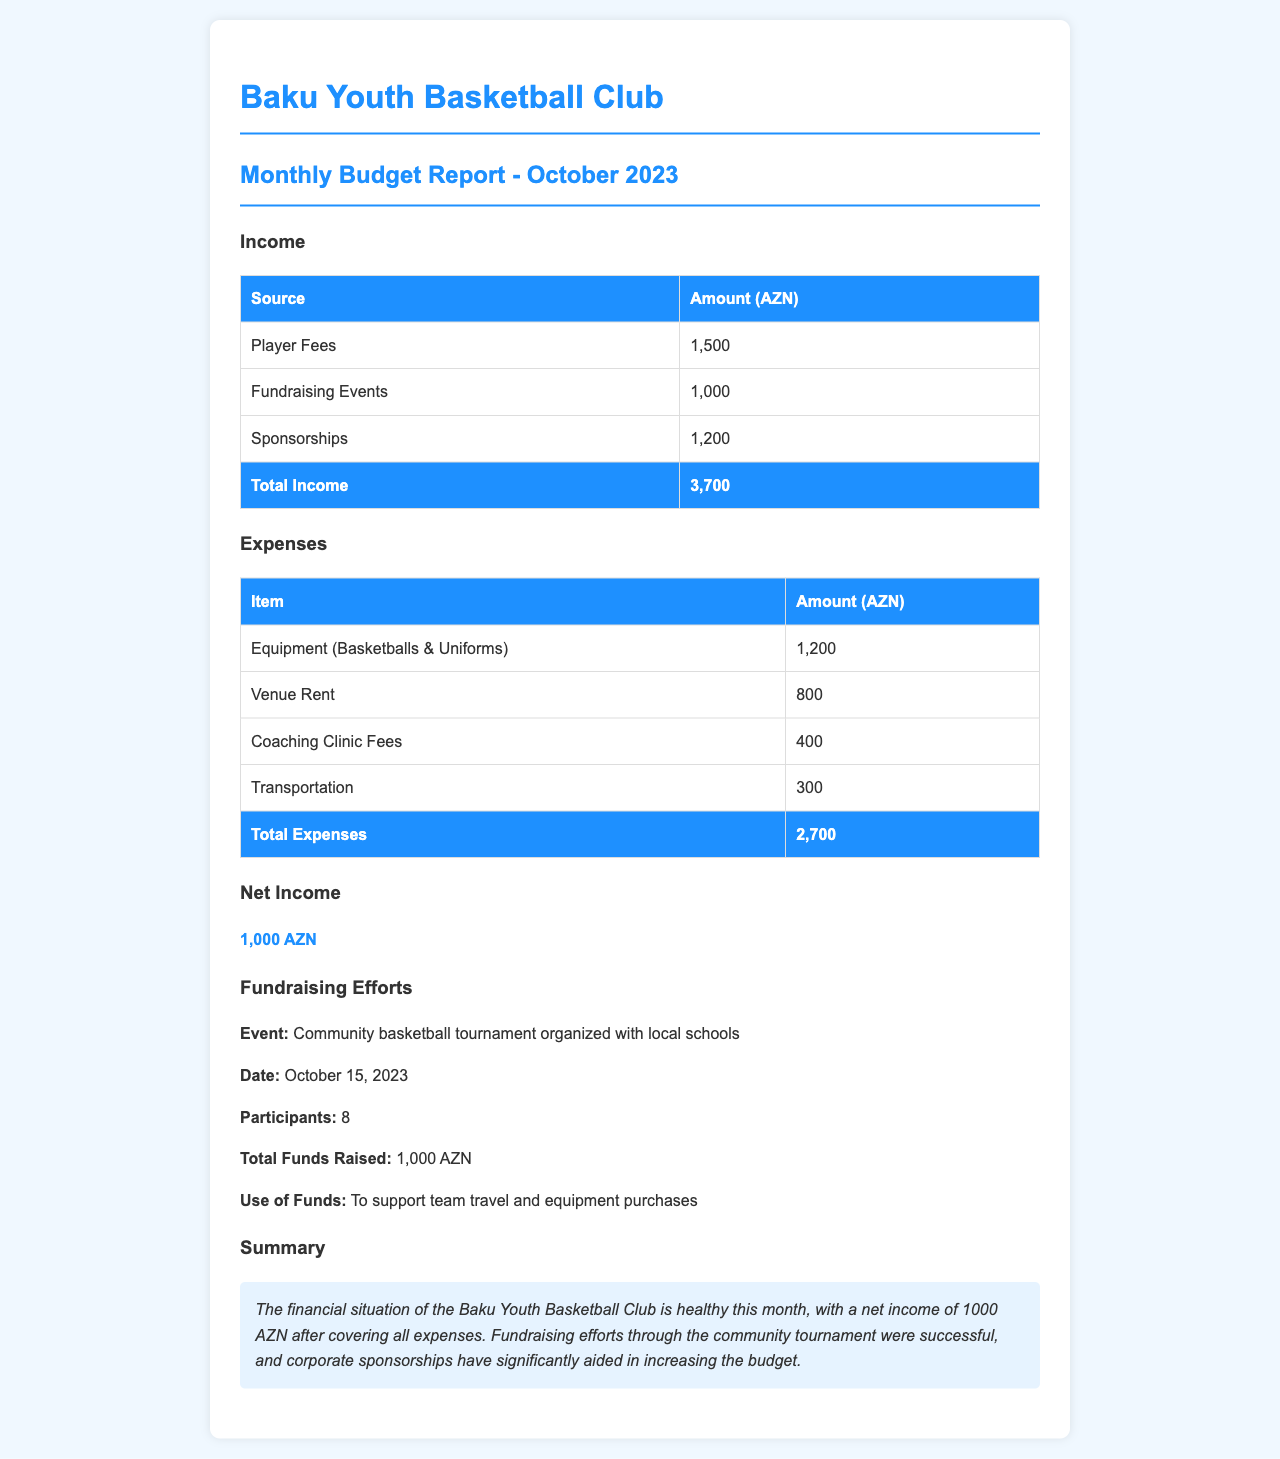What is the total income? The total income is the sum of all income sources listed in the document: 1,500 + 1,000 + 1,200.
Answer: 3,700 AZN What is the total expenses? The total expenses are calculated by adding all expenses listed in the document: 1,200 + 800 + 400 + 300.
Answer: 2,700 AZN What is the net income? The net income is derived from total income minus total expenses: 3,700 - 2,700.
Answer: 1,000 AZN What was the total funds raised from the community basketball tournament? The document specifies the total funds raised from the tournament.
Answer: 1,000 AZN When was the community tournament held? The document states the date when the fundraising event occurred.
Answer: October 15, 2023 What was the use of the funds raised? The document describes the purpose of the funds raised during the fundraising event.
Answer: To support team travel and equipment purchases How many participants were there in the tournament? The document mentions the number of participants in the fundraising event.
Answer: 8 What type of event was organized for fundraising? The document specifies the nature of the fundraising event.
Answer: Community basketball tournament What is the financial situation of the Baku Youth Basketball Club this month? The document provides a summary of the club's financial health for the month.
Answer: Healthy 